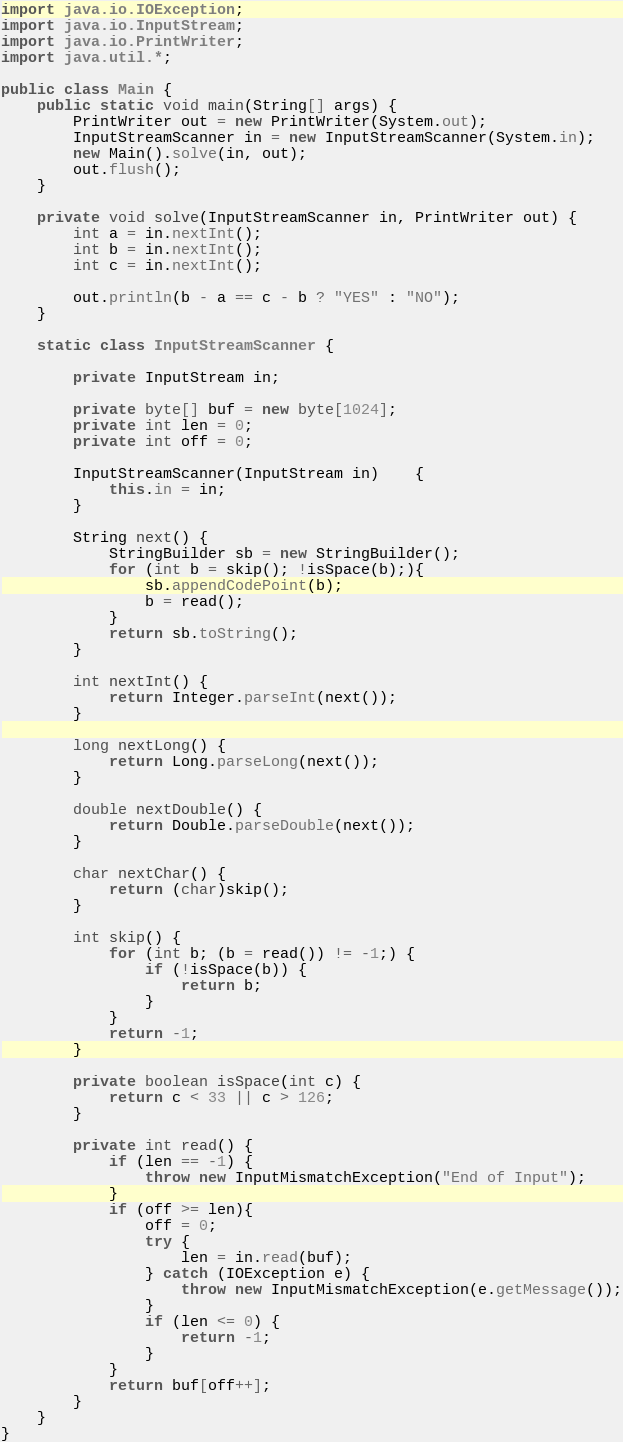Convert code to text. <code><loc_0><loc_0><loc_500><loc_500><_Java_>import java.io.IOException;
import java.io.InputStream;
import java.io.PrintWriter;
import java.util.*;

public class Main {
    public static void main(String[] args) {
        PrintWriter out = new PrintWriter(System.out);
        InputStreamScanner in = new InputStreamScanner(System.in);
        new Main().solve(in, out);
        out.flush();
    }

    private void solve(InputStreamScanner in, PrintWriter out) {
        int a = in.nextInt();
        int b = in.nextInt();
        int c = in.nextInt();

        out.println(b - a == c - b ? "YES" : "NO");
    }

    static class InputStreamScanner {

        private InputStream in;

        private byte[] buf = new byte[1024];
        private int len = 0;
        private int off = 0;

        InputStreamScanner(InputStream in)	{
            this.in = in;
        }

        String next() {
            StringBuilder sb = new StringBuilder();
            for (int b = skip(); !isSpace(b);){
                sb.appendCodePoint(b);
                b = read();
            }
            return sb.toString();
        }

        int nextInt() {
            return Integer.parseInt(next());
        }

        long nextLong() {
            return Long.parseLong(next());
        }

        double nextDouble() {
            return Double.parseDouble(next());
        }

        char nextChar() {
            return (char)skip();
        }

        int skip() {
            for (int b; (b = read()) != -1;) {
                if (!isSpace(b)) {
                    return b;
                }
            }
            return -1;
        }

        private boolean isSpace(int c) {
            return c < 33 || c > 126;
        }

        private int read() {
            if (len == -1) {
                throw new InputMismatchException("End of Input");
            }
            if (off >= len){
                off = 0;
                try {
                    len = in.read(buf);
                } catch (IOException e) {
                    throw new InputMismatchException(e.getMessage());
                }
                if (len <= 0) {
                    return -1;
                }
            }
            return buf[off++];
        }
    }
}</code> 